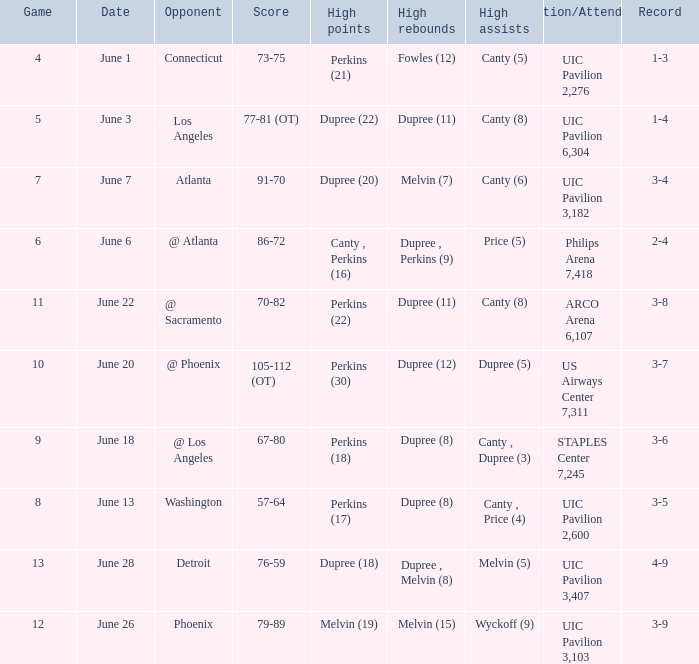What is the date of game 9? June 18. 